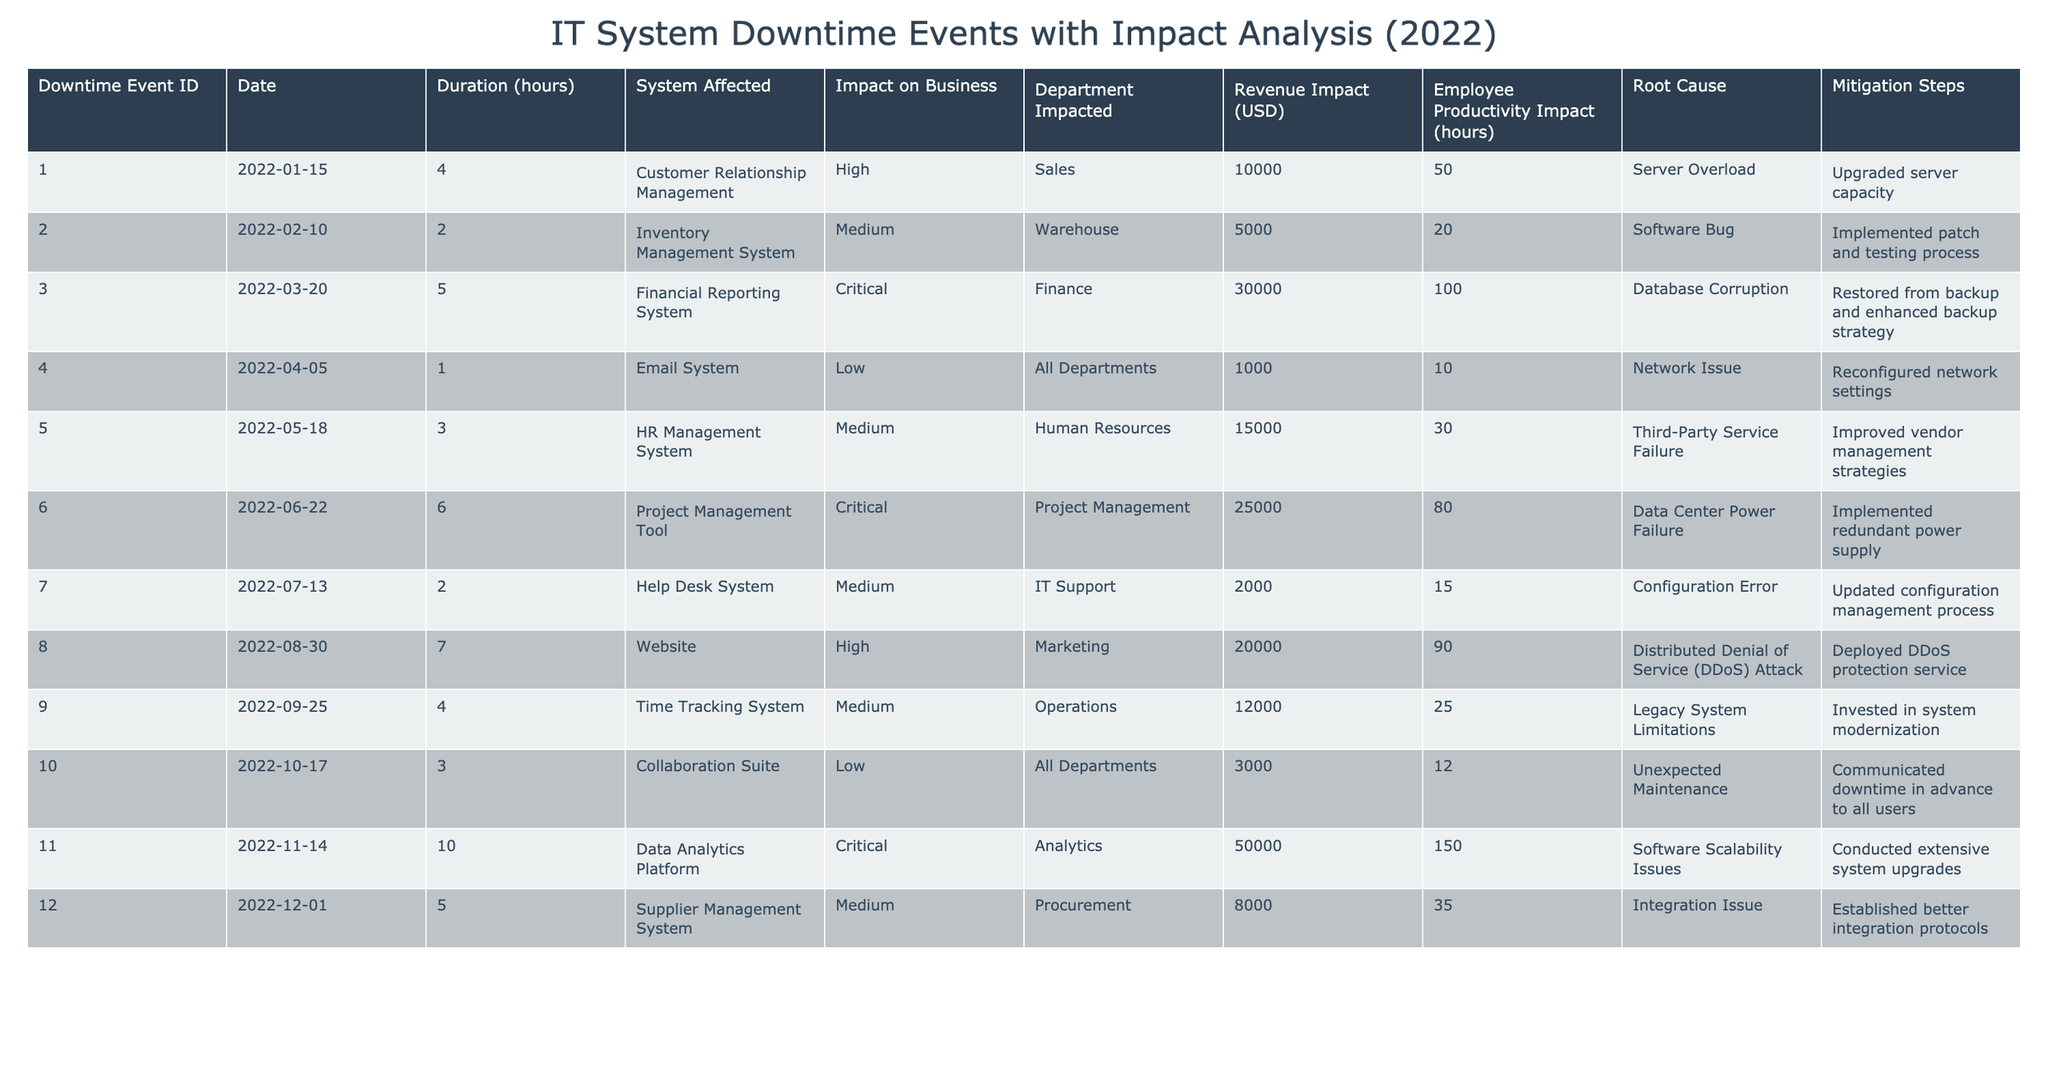What is the total duration of all downtime events in hours? There are 12 downtime events with durations of 4, 2, 5, 1, 3, 6, 2, 7, 4, 3, 10, and 5 hours. Adding them together: 4 + 2 + 5 + 1 + 3 + 6 + 2 + 7 + 4 + 3 + 10 + 5 = 52 hours.
Answer: 52 hours Which system had the highest revenue impact? By looking at the revenue impact values, the highest is $50,000 from the Data Analytics Platform.
Answer: Data Analytics Platform How many downtime events had a "Critical" impact on business? There are three events labeled as "Critical" in the impact on business column: Financial Reporting System, Project Management Tool, and Data Analytics Platform.
Answer: 3 What was the average employee productivity impact across all events? The employee productivity impacts are 50, 20, 100, 10, 30, 80, 15, 90, 25, 12, 150, and 35 hours. Summing these gives 50 + 20 + 100 + 10 + 30 + 80 + 15 + 90 + 25 + 12 + 150 + 35 = 600 hours. With 12 data points, the average is 600 / 12 = 50 hours.
Answer: 50 hours Did any downtime event result in a "Low" impact on business? Yes, there are three events with a "Low" impact: Email System, Collaboration Suite, and no other facts contradict this observation.
Answer: Yes What is the total revenue impact of downtime events categorized as "Medium"? The events with "Medium" impact have revenue impacts of $5,000, $15,000, $8,000, which sum to $5,000 + $15,000 + $8,000 = $28,000.
Answer: $28,000 Which department was impacted the most by system downtime? The Finance department had the largest productivity loss (100 hours) due to the critical event in the Financial Reporting System.
Answer: Finance How many downtime events were attributed to "Human Errors"? There are no downtime events listed in the table with "Human Errors" as the root cause, indicating none were directly attributed to this category.
Answer: 0 Calculate the difference in revenue impact between the highest and lowest impact events. The highest revenue impact is $50,000 (Data Analytics Platform) and the lowest is $1,000 (Email System). The difference is calculated as $50,000 - $1,000 = $49,000.
Answer: $49,000 What root cause is associated with the Website downtime event? The root cause for the downtime event of the Website was a Distributed Denial of Service (DDoS) Attack, as specified in the table.
Answer: DDoS Attack 